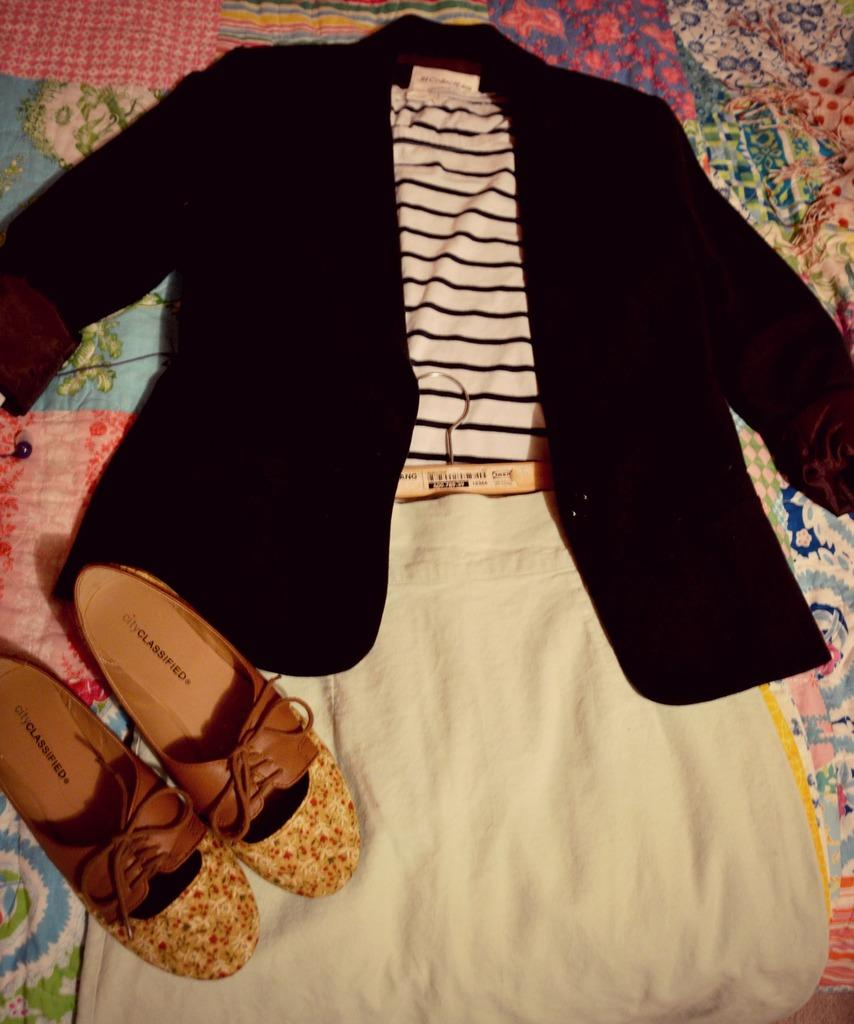<image>
Offer a succinct explanation of the picture presented. A pair of city classified women's shoes laying on a complete outfit. 